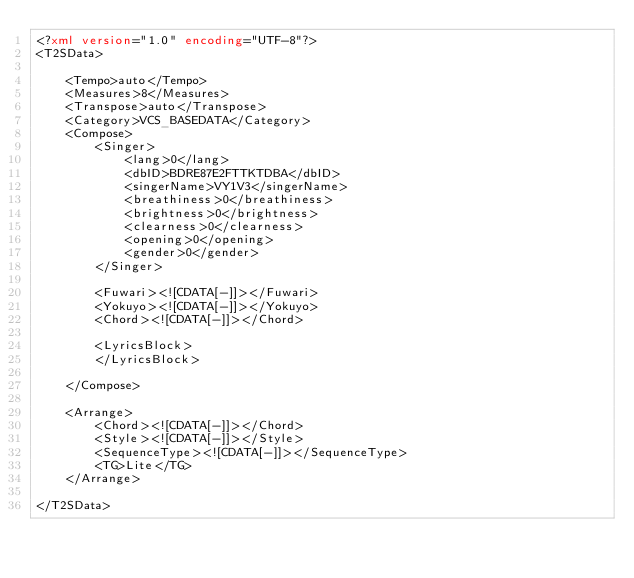Convert code to text. <code><loc_0><loc_0><loc_500><loc_500><_XML_><?xml version="1.0" encoding="UTF-8"?>
<T2SData>

    <Tempo>auto</Tempo>
    <Measures>8</Measures>
    <Transpose>auto</Transpose>
    <Category>VCS_BASEDATA</Category>
    <Compose>
        <Singer>
            <lang>0</lang>
            <dbID>BDRE87E2FTTKTDBA</dbID>
            <singerName>VY1V3</singerName>
            <breathiness>0</breathiness>
            <brightness>0</brightness>
            <clearness>0</clearness>
            <opening>0</opening>
            <gender>0</gender>
        </Singer>

        <Fuwari><![CDATA[-]]></Fuwari>
        <Yokuyo><![CDATA[-]]></Yokuyo>
        <Chord><![CDATA[-]]></Chord>

        <LyricsBlock>
        </LyricsBlock>

    </Compose>

    <Arrange>
        <Chord><![CDATA[-]]></Chord>
        <Style><![CDATA[-]]></Style>
        <SequenceType><![CDATA[-]]></SequenceType>
        <TG>Lite</TG>
    </Arrange>

</T2SData>
</code> 